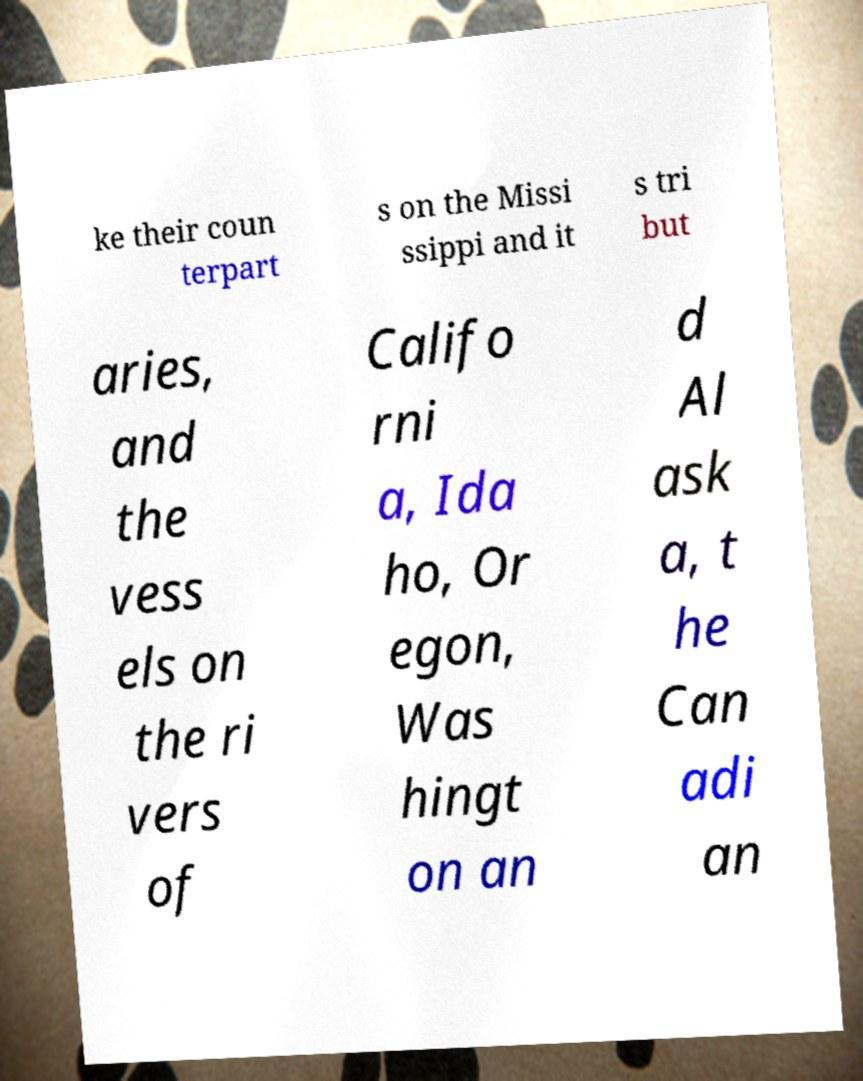For documentation purposes, I need the text within this image transcribed. Could you provide that? ke their coun terpart s on the Missi ssippi and it s tri but aries, and the vess els on the ri vers of Califo rni a, Ida ho, Or egon, Was hingt on an d Al ask a, t he Can adi an 